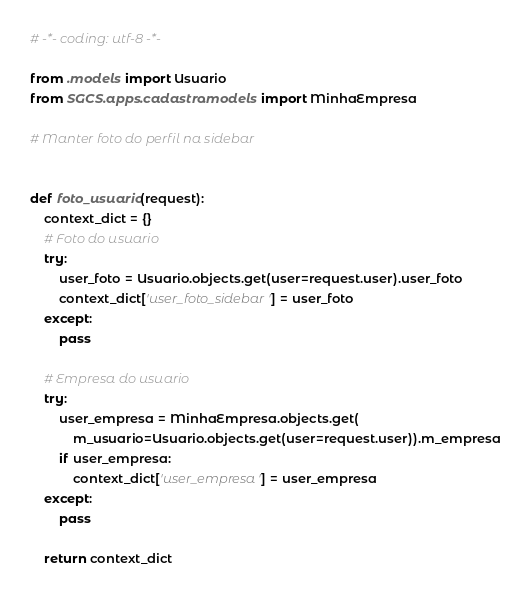<code> <loc_0><loc_0><loc_500><loc_500><_Python_># -*- coding: utf-8 -*-

from .models import Usuario
from SGCS.apps.cadastro.models import MinhaEmpresa

# Manter foto do perfil na sidebar


def foto_usuario(request):
    context_dict = {}
    # Foto do usuario
    try:
        user_foto = Usuario.objects.get(user=request.user).user_foto
        context_dict['user_foto_sidebar'] = user_foto
    except:
        pass

    # Empresa do usuario
    try:
        user_empresa = MinhaEmpresa.objects.get(
            m_usuario=Usuario.objects.get(user=request.user)).m_empresa
        if user_empresa:
            context_dict['user_empresa'] = user_empresa
    except:
        pass

    return context_dict
</code> 